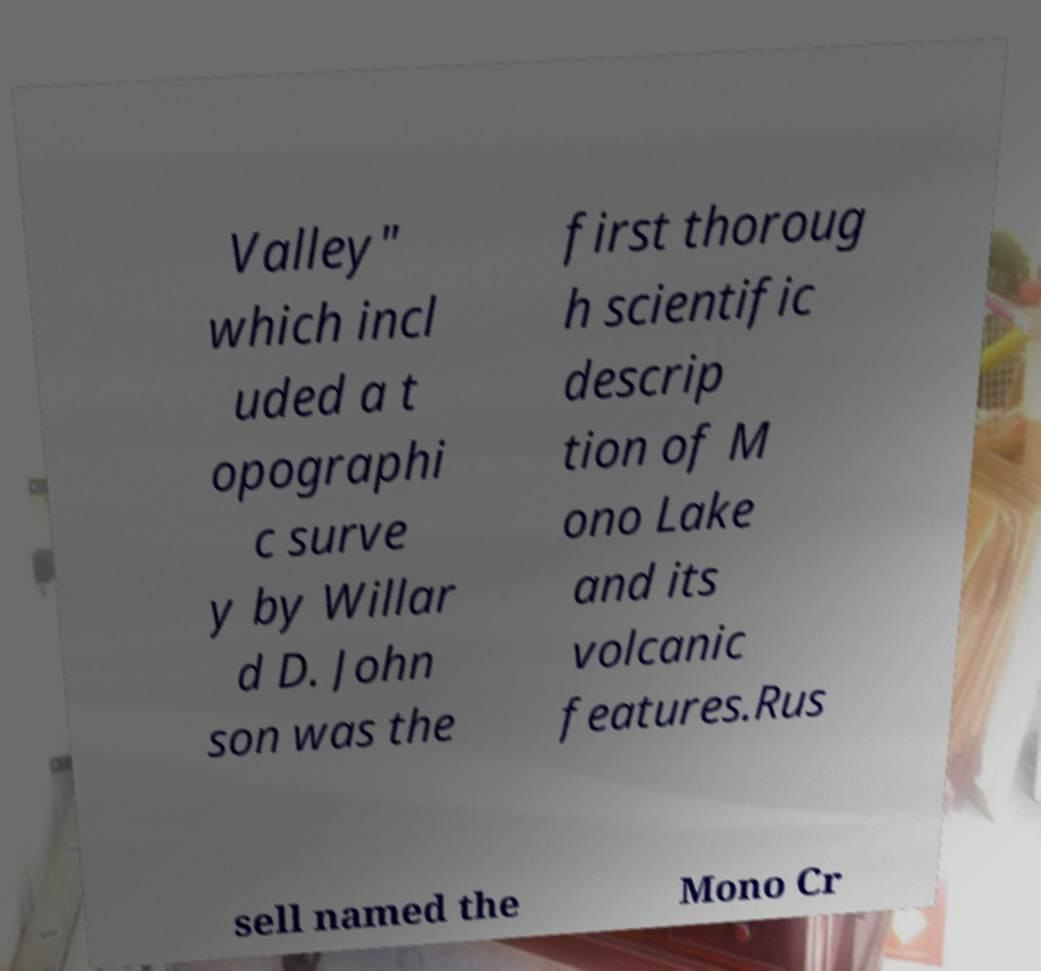Please identify and transcribe the text found in this image. Valley" which incl uded a t opographi c surve y by Willar d D. John son was the first thoroug h scientific descrip tion of M ono Lake and its volcanic features.Rus sell named the Mono Cr 